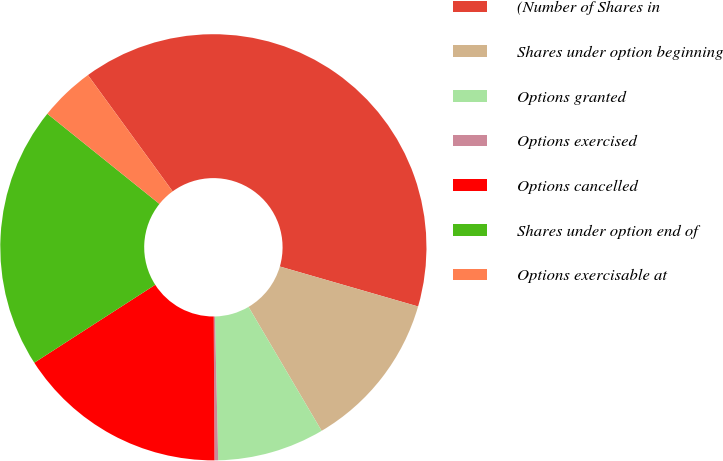Convert chart to OTSL. <chart><loc_0><loc_0><loc_500><loc_500><pie_chart><fcel>(Number of Shares in<fcel>Shares under option beginning<fcel>Options granted<fcel>Options exercised<fcel>Options cancelled<fcel>Shares under option end of<fcel>Options exercisable at<nl><fcel>39.5%<fcel>12.04%<fcel>8.12%<fcel>0.28%<fcel>15.97%<fcel>19.89%<fcel>4.2%<nl></chart> 